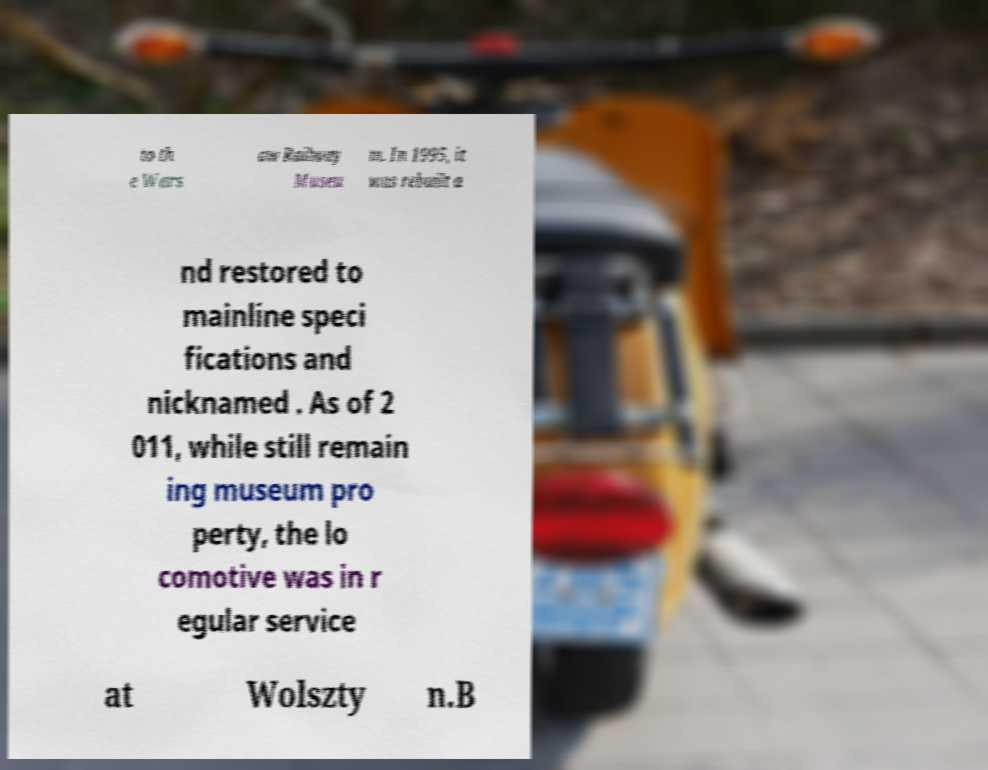Please identify and transcribe the text found in this image. to th e Wars aw Railway Museu m. In 1995, it was rebuilt a nd restored to mainline speci fications and nicknamed . As of 2 011, while still remain ing museum pro perty, the lo comotive was in r egular service at Wolszty n.B 